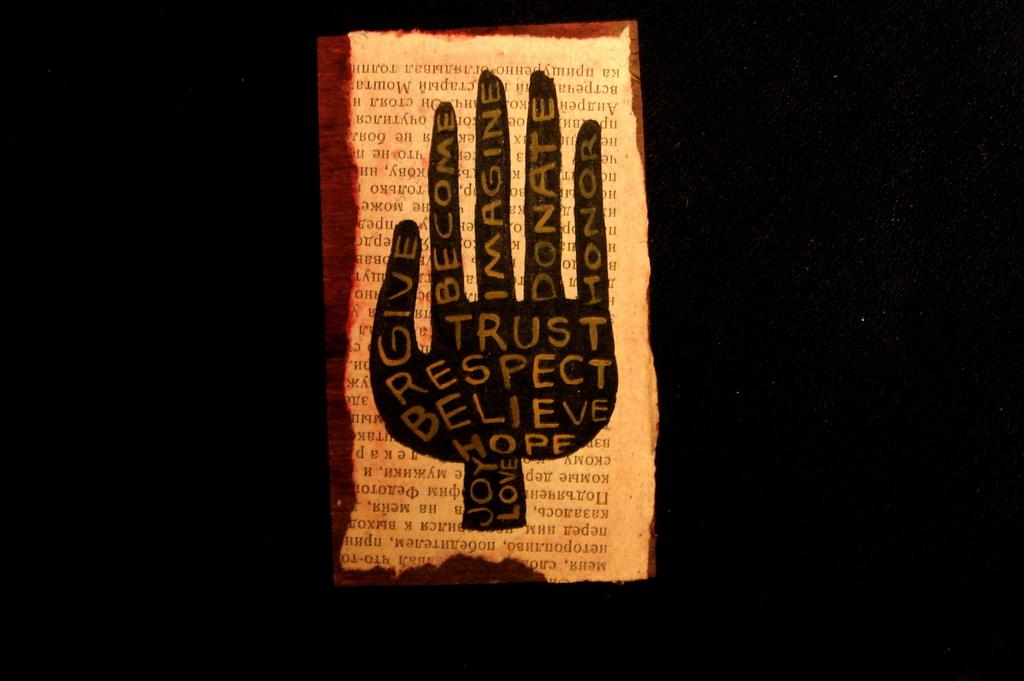How many virtues can you see?
Provide a succinct answer. 11. 